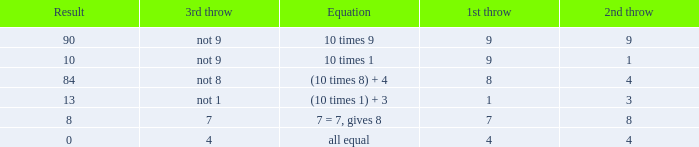Could you help me parse every detail presented in this table? {'header': ['Result', '3rd throw', 'Equation', '1st throw', '2nd throw'], 'rows': [['90', 'not 9', '10 times 9', '9', '9'], ['10', 'not 9', '10 times 1', '9', '1'], ['84', 'not 8', '(10 times 8) + 4', '8', '4'], ['13', 'not 1', '(10 times 1) + 3', '1', '3'], ['8', '7', '7 = 7, gives 8', '7', '8'], ['0', '4', 'all equal', '4', '4']]} If the equation is (10 times 8) + 4, what would be the 2nd throw? 4.0. 